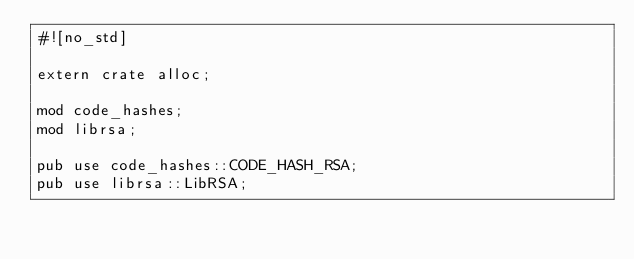Convert code to text. <code><loc_0><loc_0><loc_500><loc_500><_Rust_>#![no_std]

extern crate alloc;

mod code_hashes;
mod librsa;

pub use code_hashes::CODE_HASH_RSA;
pub use librsa::LibRSA;</code> 